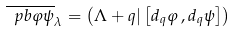Convert formula to latex. <formula><loc_0><loc_0><loc_500><loc_500>\overline { \ p b { \varphi } { \psi } } _ { \lambda } = \left ( \Lambda + q | \left [ d _ { q } \varphi \, , d _ { q } \psi \right ] \right )</formula> 